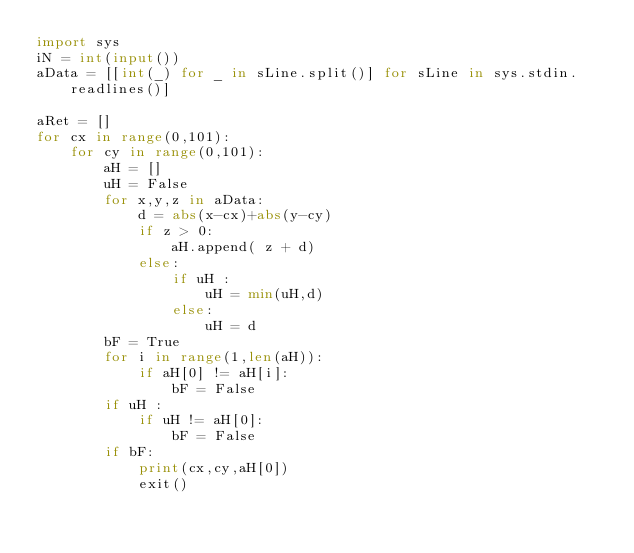<code> <loc_0><loc_0><loc_500><loc_500><_Python_>import sys
iN = int(input())
aData = [[int(_) for _ in sLine.split()] for sLine in sys.stdin.readlines()]

aRet = []
for cx in range(0,101):
    for cy in range(0,101):
        aH = []
        uH = False
        for x,y,z in aData:
            d = abs(x-cx)+abs(y-cy)
            if z > 0:
                aH.append( z + d)
            else:
                if uH :
                    uH = min(uH,d)
                else:
                    uH = d
        bF = True
        for i in range(1,len(aH)):
            if aH[0] != aH[i]:
                bF = False
        if uH :
            if uH != aH[0]:
                bF = False
        if bF:
            print(cx,cy,aH[0])
            exit()
</code> 